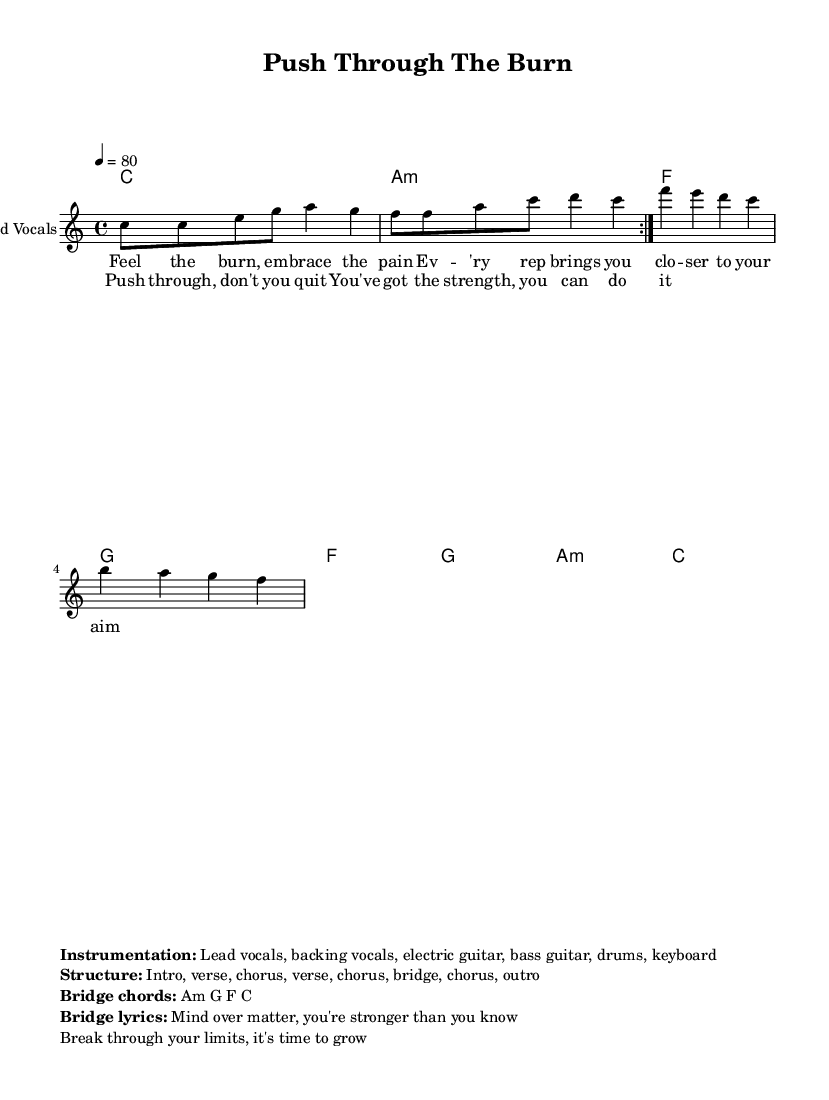What is the key signature of this music? The key signature is C major, which has no sharps or flats.
Answer: C major What is the time signature of this music? The time signature is indicated as 4/4, which means there are four beats in each measure.
Answer: 4/4 What is the tempo marking of this piece? The tempo is marked as quarter note equals 80 beats per minute, indicating the speed of the music.
Answer: 80 How many verses are in the structure of the song? The structure includes two verses along with the chorus and bridge, making a total of two verses.
Answer: 2 What is the primary theme of the lyrics? The lyrics focus on motivation and perseverance through difficult workouts, encouraging the listener to push beyond limits.
Answer: Motivation What instruments are listed in the instrumentation? The instrumentation includes lead vocals, backing vocals, electric guitar, bass guitar, drums, and keyboard, providing a rich sound typical of reggae music.
Answer: Lead vocals, backing vocals, electric guitar, bass guitar, drums, keyboard What chords are mentioned in the bridge section? The bridge section is established with the chords A minor, G, F, and C, which are common in reggae and contribute to the song's rhythmic feel.
Answer: A minor, G, F, C 